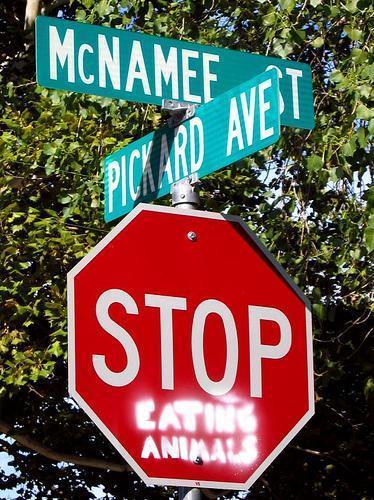How many street names are shown?
Give a very brief answer. 2. 